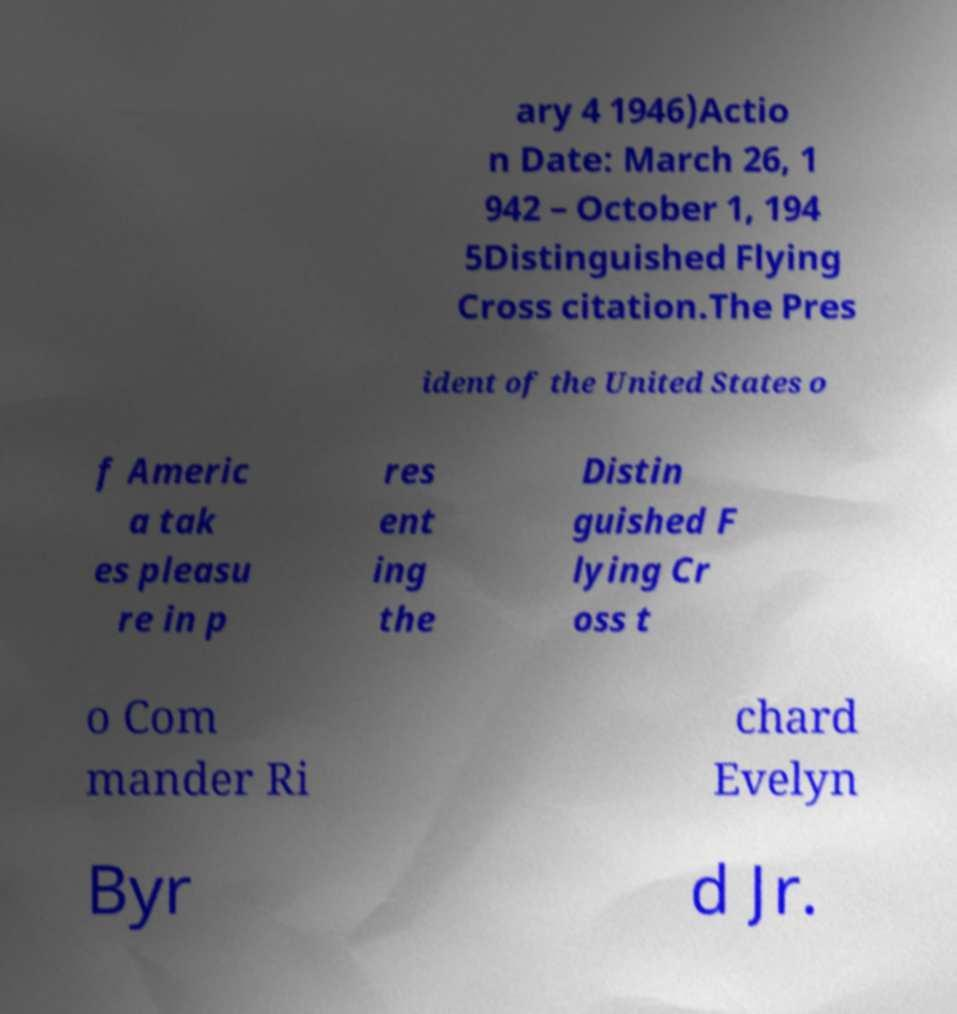For documentation purposes, I need the text within this image transcribed. Could you provide that? ary 4 1946)Actio n Date: March 26, 1 942 – October 1, 194 5Distinguished Flying Cross citation.The Pres ident of the United States o f Americ a tak es pleasu re in p res ent ing the Distin guished F lying Cr oss t o Com mander Ri chard Evelyn Byr d Jr. 